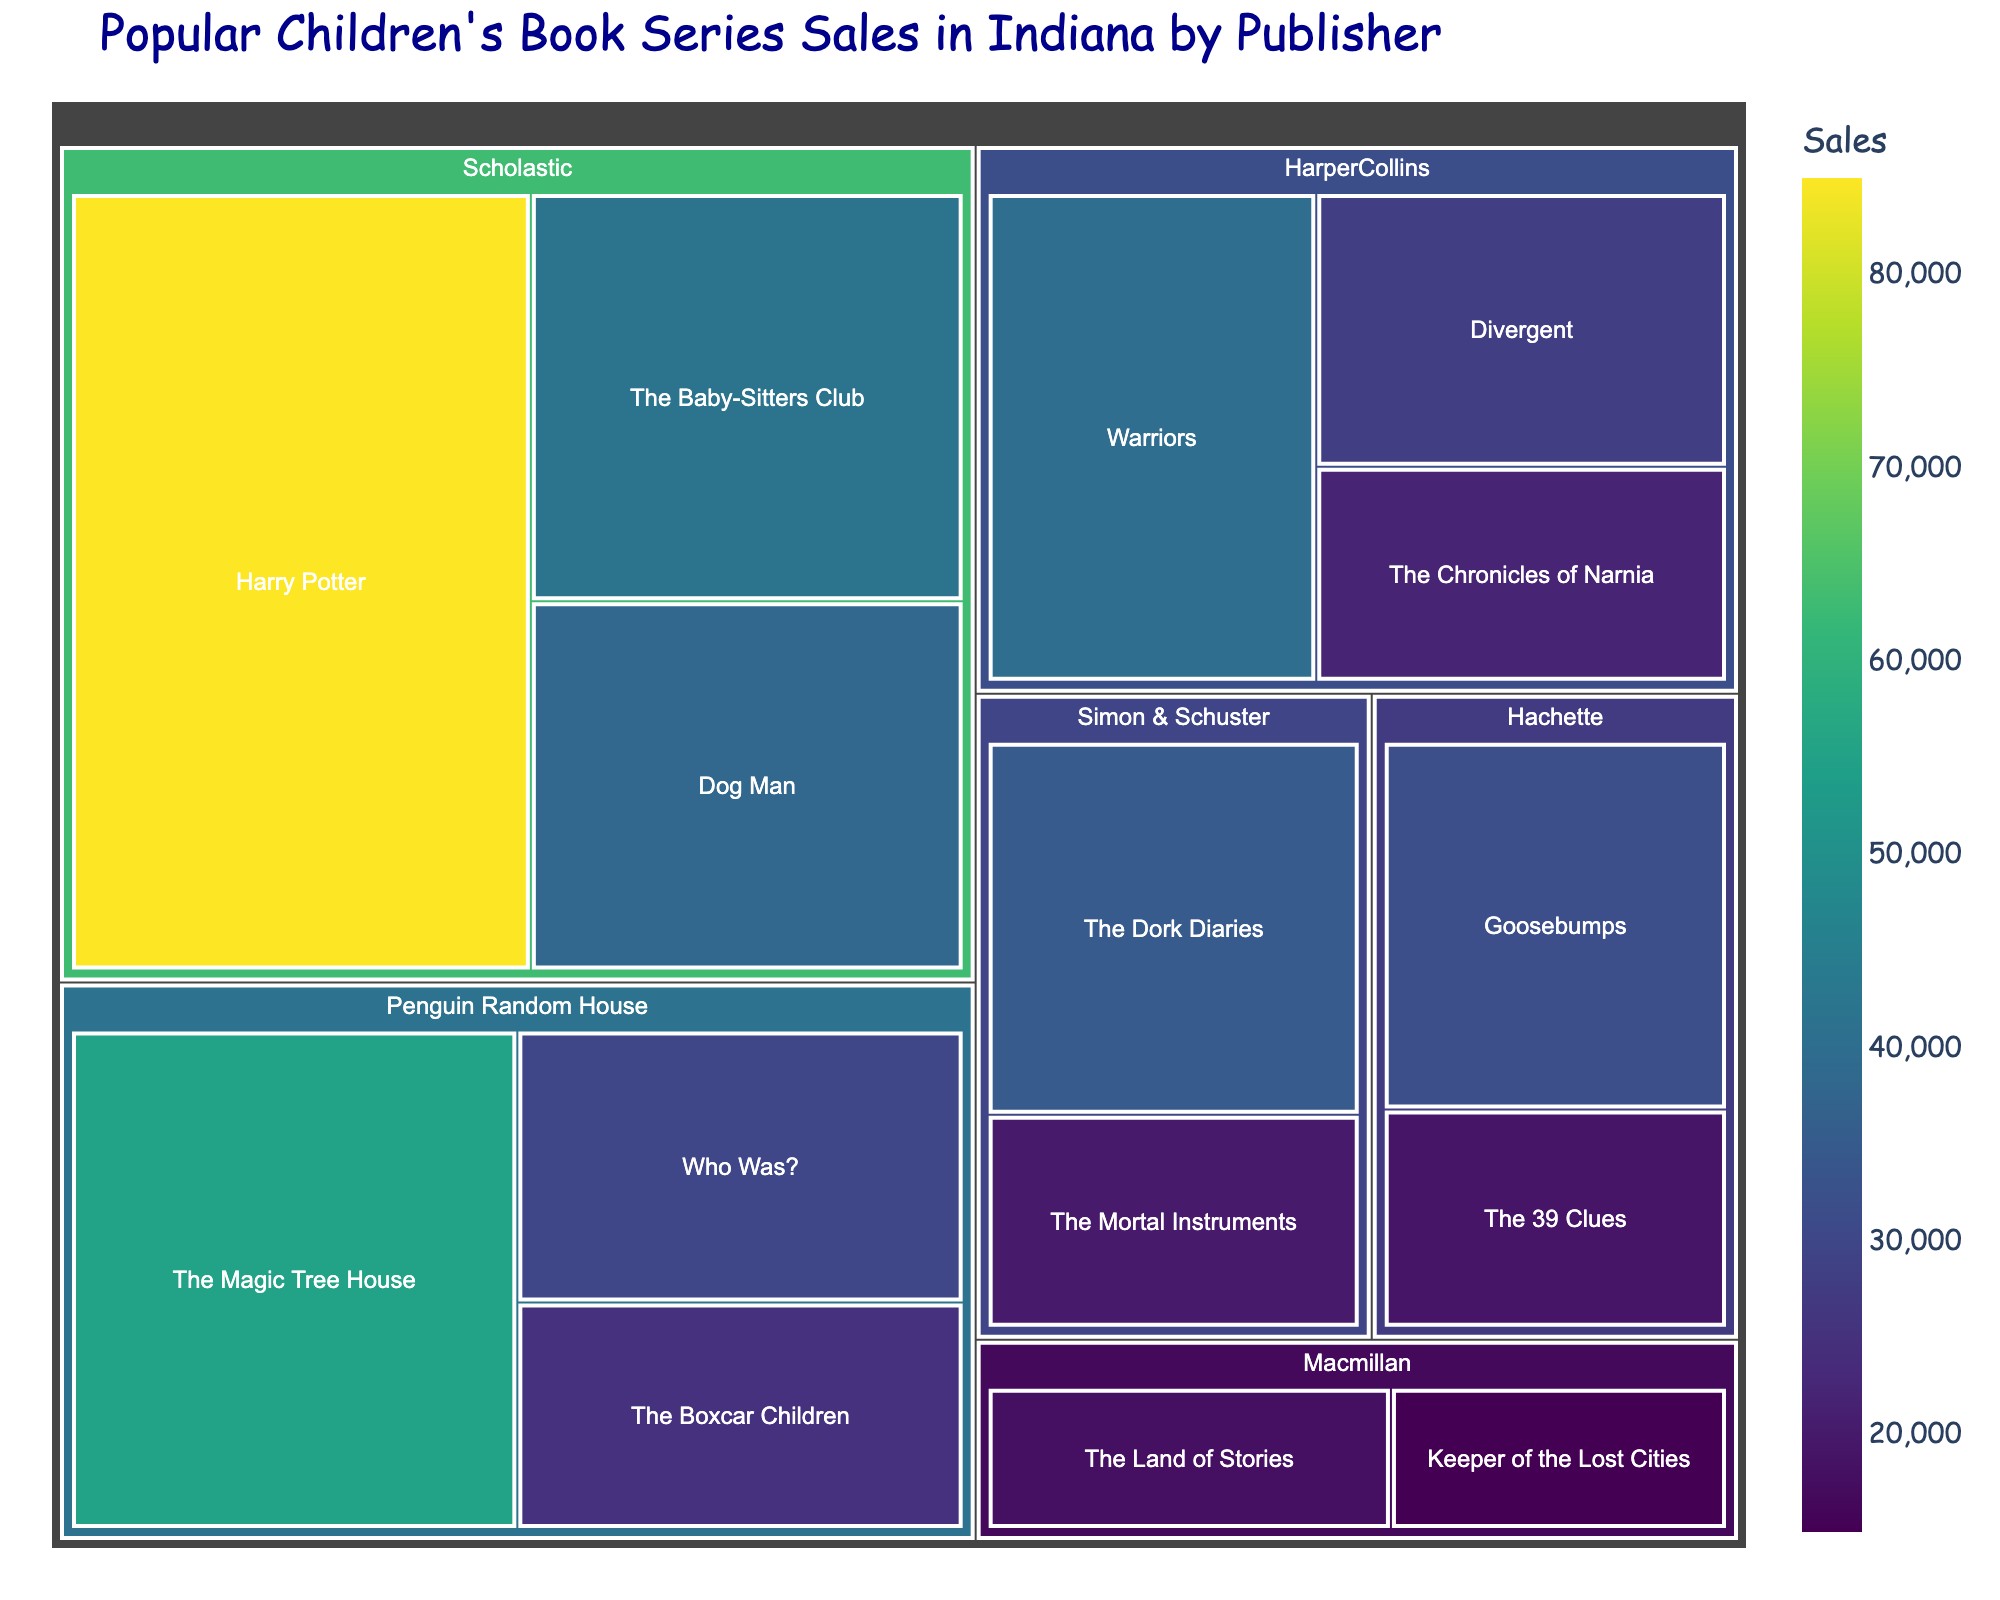Which publisher has the highest total sales? By summing up the sales for each series under each publisher, we can find the total sales. Scholastic: 85000 (Harry Potter) + 42000 (The Baby-Sitters Club) + 38000 (Dog Man) = 165000, Penguin Random House: 55000 (The Magic Tree House) + 30000 (Who Was?) + 25000 (The Boxcar Children) = 110000, HarperCollins: 40000 (Warriors) + 28000 (Divergent) + 22000 (The Chronicles of Narnia) = 90000, Simon & Schuster: 35000 (The Dork Diaries) + 20000 (The Mortal Instruments) = 55000, Macmillan: 18000 (The Land of Stories) + 15000 (Keeper of the Lost Cities) = 33000, Hachette: 32000 (Goosebumps) + 19000 (The 39 Clues) = 51000. Therefore, Scholastic has the highest total sales.
Answer: Scholastic Which book series has the highest individual sales? The sales for each series are displayed on the treemap. Harry Potter has the highest individual sales of 85000.
Answer: Harry Potter Which publisher has the least number of series in the top-selling category? Count the number of series for each publisher. Scholastic has three series, Penguin Random House has three series, HarperCollins has three series, Simon & Schuster has two series, Hachette has two series, and Macmillan has two series. Therefore, Macmillan and Hachette have the least number of series.
Answer: Macmillan and Hachette How do the total sales of series under Simon & Schuster compare to those under Hachette? Total sales for Simon & Schuster: 35000 (The Dork Diaries) + 20000 (The Mortal Instruments) = 55000. Total sales for Hachette: 32000 (Goosebumps) + 19000 (The 39 Clues) = 51000. So, Simon & Schuster has higher total sales than Hachette.
Answer: Simon & Schuster What is the combined sales figure for 'The Baby-Sitters Club' and 'Dog Man'? Adding the sales for 'The Baby-Sitters Club' (42000) and 'Dog Man' (38000), we get 42000 + 38000 = 80000.
Answer: 80000 What is the average sales figure for series under HarperCollins? Summing up the sales for series under HarperCollins: 40000 (Warriors) + 28000 (Divergent) + 22000 (The Chronicles of Narnia) = 90000. There are 3 series, so the average is 90000 / 3 = 30000.
Answer: 30000 